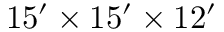<formula> <loc_0><loc_0><loc_500><loc_500>1 5 ^ { \prime } \times 1 5 ^ { \prime } \times 1 2 ^ { \prime }</formula> 